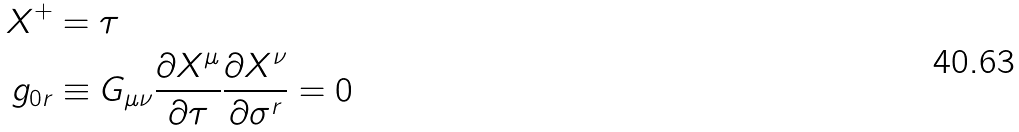Convert formula to latex. <formula><loc_0><loc_0><loc_500><loc_500>X ^ { + } & = \tau \\ g _ { 0 r } & \equiv G _ { \mu \nu } \frac { \partial X ^ { \mu } } { \partial \tau } \frac { \partial X ^ { \nu } } { \partial \sigma ^ { r } } = 0</formula> 